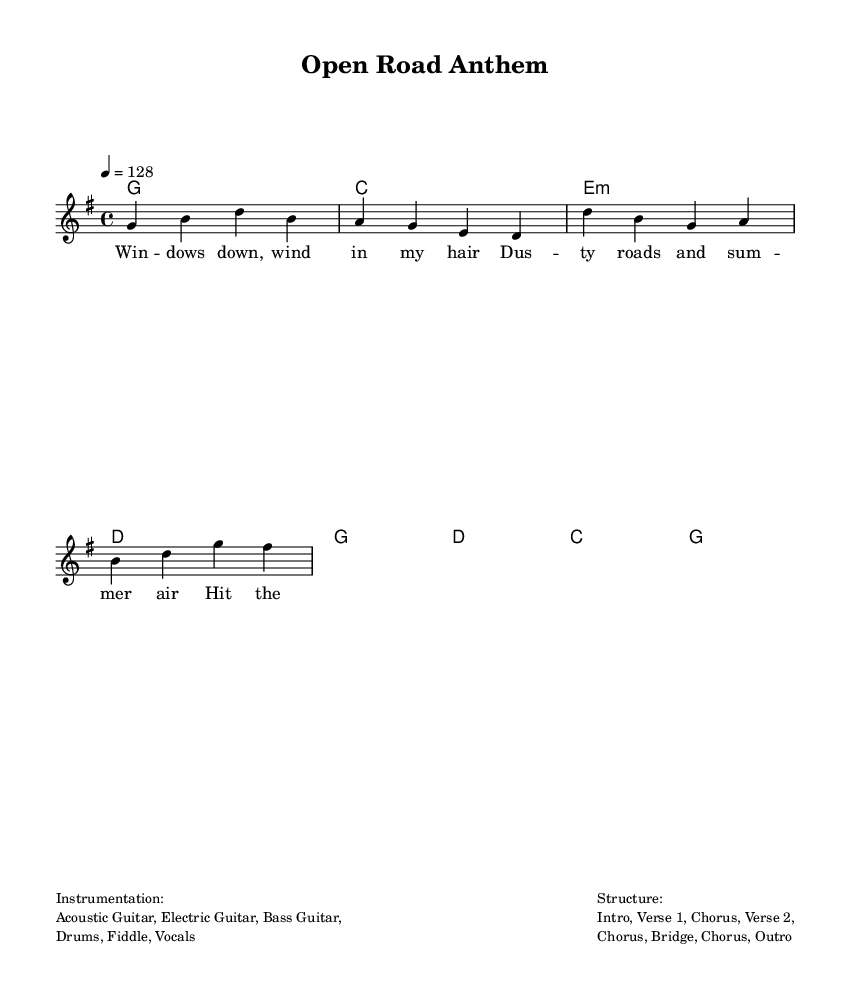What is the key signature of this music? The key signature is G major, as indicated by one sharp (F#) in the key signature section at the beginning of the score.
Answer: G major What is the time signature of this piece? The time signature is 4/4, which means there are four beats per measure and the quarter note receives one beat. This can be identified in the time signature section at the beginning.
Answer: 4/4 What is the tempo marking for the piece? The tempo marking is 128 beats per minute, which is specified as "4 = 128" following the tempo indication in the score.
Answer: 128 How many verses are there in the structure of the song? The song structure includes the terms "Verse 1" and "Verse 2," indicating there are two distinct verses in the piece.
Answer: 2 What are the primary instruments used in this arrangement? The score lists "Acoustic Guitar, Electric Guitar, Bass Guitar, Drums, Fiddle, Vocals" as the instrumentation, which gives a clear indication of the primary instruments used in this arrangement.
Answer: Acoustic Guitar, Electric Guitar, Bass Guitar, Drums, Fiddle, Vocals What is the main theme of the lyrics in this anthem? The lyrics focus on themes of freedom and adventure, with phrases like "Hit the road, let's break free" suggesting a carefree spirit and desire for exploration. This reflects the typical country rock vibe of road trips and summer adventures.
Answer: Freedom and adventure 